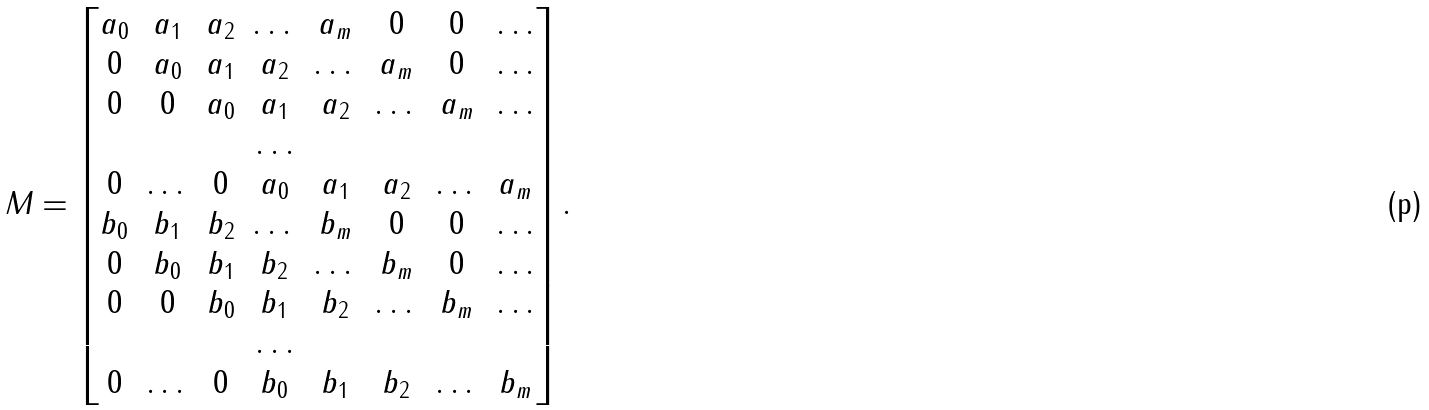<formula> <loc_0><loc_0><loc_500><loc_500>M = \begin{bmatrix} a _ { 0 } & a _ { 1 } & a _ { 2 } & \dots & a _ { m } & 0 & 0 & \dots \\ 0 & a _ { 0 } & a _ { 1 } & a _ { 2 } & \dots & a _ { m } & 0 & \dots \\ 0 & 0 & a _ { 0 } & a _ { 1 } & a _ { 2 } & \dots & a _ { m } & \dots \\ & & & \dots \\ 0 & \dots & 0 & a _ { 0 } & a _ { 1 } & a _ { 2 } & \dots & a _ { m } \\ b _ { 0 } & b _ { 1 } & b _ { 2 } & \dots & b _ { m } & 0 & 0 & \dots \\ 0 & b _ { 0 } & b _ { 1 } & b _ { 2 } & \dots & b _ { m } & 0 & \dots \\ 0 & 0 & b _ { 0 } & b _ { 1 } & b _ { 2 } & \dots & b _ { m } & \dots \\ & & & \dots \\ 0 & \dots & 0 & b _ { 0 } & b _ { 1 } & b _ { 2 } & \dots & b _ { m } \end{bmatrix} .</formula> 